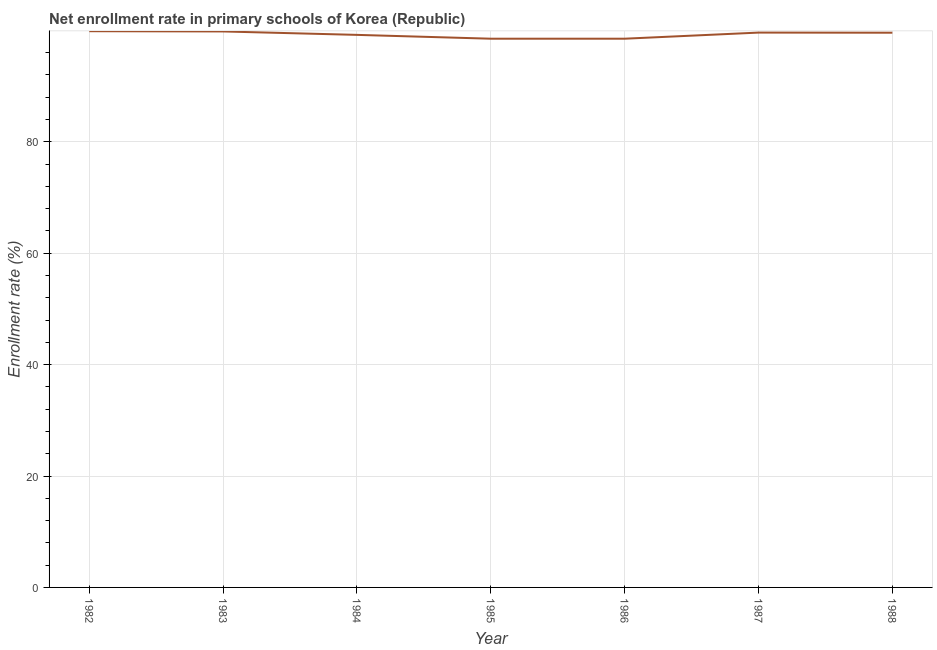What is the net enrollment rate in primary schools in 1988?
Make the answer very short. 99.59. Across all years, what is the maximum net enrollment rate in primary schools?
Keep it short and to the point. 99.86. Across all years, what is the minimum net enrollment rate in primary schools?
Offer a terse response. 98.51. What is the sum of the net enrollment rate in primary schools?
Your answer should be compact. 695.09. What is the difference between the net enrollment rate in primary schools in 1986 and 1988?
Keep it short and to the point. -1.07. What is the average net enrollment rate in primary schools per year?
Your answer should be compact. 99.3. What is the median net enrollment rate in primary schools?
Keep it short and to the point. 99.59. Do a majority of the years between 1986 and 1983 (inclusive) have net enrollment rate in primary schools greater than 60 %?
Your answer should be very brief. Yes. What is the ratio of the net enrollment rate in primary schools in 1983 to that in 1985?
Provide a succinct answer. 1.01. Is the difference between the net enrollment rate in primary schools in 1984 and 1987 greater than the difference between any two years?
Ensure brevity in your answer.  No. What is the difference between the highest and the second highest net enrollment rate in primary schools?
Offer a terse response. 0.04. Is the sum of the net enrollment rate in primary schools in 1985 and 1987 greater than the maximum net enrollment rate in primary schools across all years?
Your answer should be compact. Yes. What is the difference between the highest and the lowest net enrollment rate in primary schools?
Offer a terse response. 1.35. Does the net enrollment rate in primary schools monotonically increase over the years?
Offer a terse response. No. How many years are there in the graph?
Keep it short and to the point. 7. What is the difference between two consecutive major ticks on the Y-axis?
Ensure brevity in your answer.  20. Does the graph contain any zero values?
Ensure brevity in your answer.  No. Does the graph contain grids?
Make the answer very short. Yes. What is the title of the graph?
Make the answer very short. Net enrollment rate in primary schools of Korea (Republic). What is the label or title of the X-axis?
Give a very brief answer. Year. What is the label or title of the Y-axis?
Offer a terse response. Enrollment rate (%). What is the Enrollment rate (%) of 1982?
Offer a very short reply. 99.86. What is the Enrollment rate (%) of 1983?
Provide a short and direct response. 99.81. What is the Enrollment rate (%) in 1984?
Offer a very short reply. 99.2. What is the Enrollment rate (%) in 1985?
Your answer should be compact. 98.51. What is the Enrollment rate (%) of 1986?
Your answer should be compact. 98.51. What is the Enrollment rate (%) of 1987?
Provide a short and direct response. 99.61. What is the Enrollment rate (%) in 1988?
Provide a short and direct response. 99.59. What is the difference between the Enrollment rate (%) in 1982 and 1983?
Offer a very short reply. 0.04. What is the difference between the Enrollment rate (%) in 1982 and 1984?
Provide a succinct answer. 0.66. What is the difference between the Enrollment rate (%) in 1982 and 1985?
Make the answer very short. 1.35. What is the difference between the Enrollment rate (%) in 1982 and 1986?
Make the answer very short. 1.35. What is the difference between the Enrollment rate (%) in 1982 and 1987?
Make the answer very short. 0.25. What is the difference between the Enrollment rate (%) in 1982 and 1988?
Your answer should be compact. 0.27. What is the difference between the Enrollment rate (%) in 1983 and 1984?
Your answer should be compact. 0.62. What is the difference between the Enrollment rate (%) in 1983 and 1985?
Give a very brief answer. 1.3. What is the difference between the Enrollment rate (%) in 1983 and 1986?
Keep it short and to the point. 1.3. What is the difference between the Enrollment rate (%) in 1983 and 1987?
Make the answer very short. 0.21. What is the difference between the Enrollment rate (%) in 1983 and 1988?
Provide a short and direct response. 0.23. What is the difference between the Enrollment rate (%) in 1984 and 1985?
Your response must be concise. 0.69. What is the difference between the Enrollment rate (%) in 1984 and 1986?
Ensure brevity in your answer.  0.69. What is the difference between the Enrollment rate (%) in 1984 and 1987?
Offer a terse response. -0.41. What is the difference between the Enrollment rate (%) in 1984 and 1988?
Make the answer very short. -0.39. What is the difference between the Enrollment rate (%) in 1985 and 1986?
Provide a succinct answer. 0. What is the difference between the Enrollment rate (%) in 1985 and 1987?
Make the answer very short. -1.09. What is the difference between the Enrollment rate (%) in 1985 and 1988?
Your answer should be very brief. -1.07. What is the difference between the Enrollment rate (%) in 1986 and 1987?
Make the answer very short. -1.09. What is the difference between the Enrollment rate (%) in 1986 and 1988?
Keep it short and to the point. -1.07. What is the difference between the Enrollment rate (%) in 1987 and 1988?
Offer a very short reply. 0.02. What is the ratio of the Enrollment rate (%) in 1982 to that in 1985?
Your answer should be compact. 1.01. What is the ratio of the Enrollment rate (%) in 1982 to that in 1986?
Provide a succinct answer. 1.01. What is the ratio of the Enrollment rate (%) in 1982 to that in 1987?
Make the answer very short. 1. What is the ratio of the Enrollment rate (%) in 1983 to that in 1984?
Your answer should be compact. 1.01. What is the ratio of the Enrollment rate (%) in 1983 to that in 1985?
Your answer should be very brief. 1.01. What is the ratio of the Enrollment rate (%) in 1983 to that in 1987?
Your answer should be very brief. 1. What is the ratio of the Enrollment rate (%) in 1983 to that in 1988?
Make the answer very short. 1. What is the ratio of the Enrollment rate (%) in 1984 to that in 1985?
Offer a terse response. 1.01. What is the ratio of the Enrollment rate (%) in 1984 to that in 1988?
Ensure brevity in your answer.  1. What is the ratio of the Enrollment rate (%) in 1985 to that in 1986?
Give a very brief answer. 1. What is the ratio of the Enrollment rate (%) in 1986 to that in 1987?
Provide a short and direct response. 0.99. What is the ratio of the Enrollment rate (%) in 1987 to that in 1988?
Your answer should be compact. 1. 